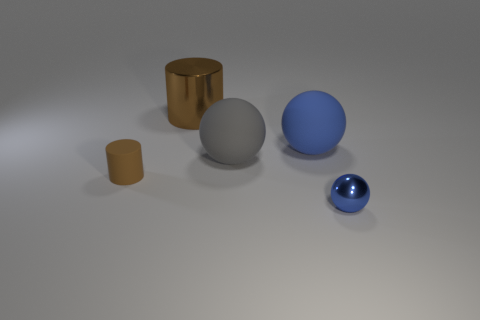Subtract all brown spheres. Subtract all green blocks. How many spheres are left? 3 Add 3 gray rubber balls. How many objects exist? 8 Subtract all spheres. How many objects are left? 2 Subtract 0 green cylinders. How many objects are left? 5 Subtract all red rubber things. Subtract all large gray objects. How many objects are left? 4 Add 1 big metal cylinders. How many big metal cylinders are left? 2 Add 3 red rubber spheres. How many red rubber spheres exist? 3 